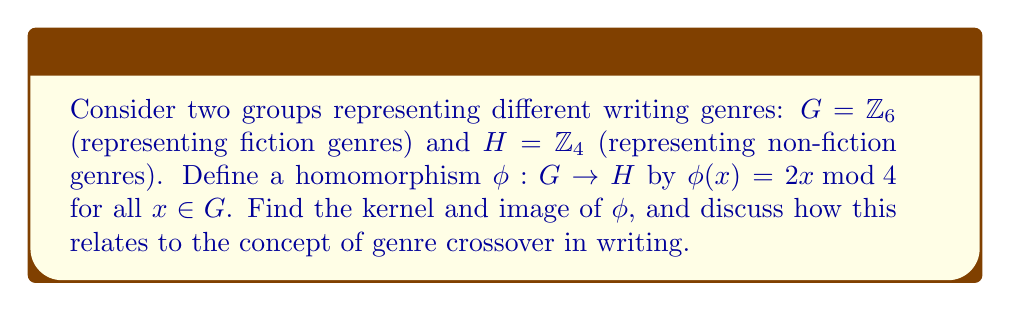Give your solution to this math problem. To find the kernel and image of the homomorphism $\phi$, we need to follow these steps:

1. Kernel:
The kernel of $\phi$ is the set of all elements in $G$ that map to the identity element in $H$. In this case, the identity element in $H$ is 0.

$\ker(\phi) = \{x \in G : \phi(x) = 0\}$

Let's evaluate $\phi(x)$ for each element in $G$:

$\phi(0) = 2 \cdot 0 \bmod 4 = 0$
$\phi(1) = 2 \cdot 1 \bmod 4 = 2$
$\phi(2) = 2 \cdot 2 \bmod 4 = 0$
$\phi(3) = 2 \cdot 3 \bmod 4 = 2$
$\phi(4) = 2 \cdot 4 \bmod 4 = 0$
$\phi(5) = 2 \cdot 5 \bmod 4 = 2$

We can see that $\phi(x) = 0$ when $x = 0, 2, 4$. Therefore, $\ker(\phi) = \{0, 2, 4\}$.

2. Image:
The image of $\phi$ is the set of all elements in $H$ that are mapped to by some element in $G$.

$\text{Im}(\phi) = \{\phi(x) : x \in G\}$

From our calculations above, we can see that the only possible values for $\phi(x)$ are 0 and 2. Therefore, $\text{Im}(\phi) = \{0, 2\}$.

Relating this to genre crossover:
The kernel represents elements in the fiction genre group that map to the identity in the non-fiction genre group. This could be interpreted as fiction genres that have no direct equivalent in non-fiction. The fact that the kernel is non-trivial (contains elements other than the identity) suggests that there are some fiction genres that don't have a clear non-fiction counterpart.

The image represents the subset of non-fiction genres that can be reached from fiction genres through this mapping. The fact that the image is a proper subset of $H$ implies that not all non-fiction genres have a corresponding fiction genre under this particular mapping, highlighting the distinct nature of some non-fiction writing styles.
Answer: Kernel: $\ker(\phi) = \{0, 2, 4\}$
Image: $\text{Im}(\phi) = \{0, 2\}$ 